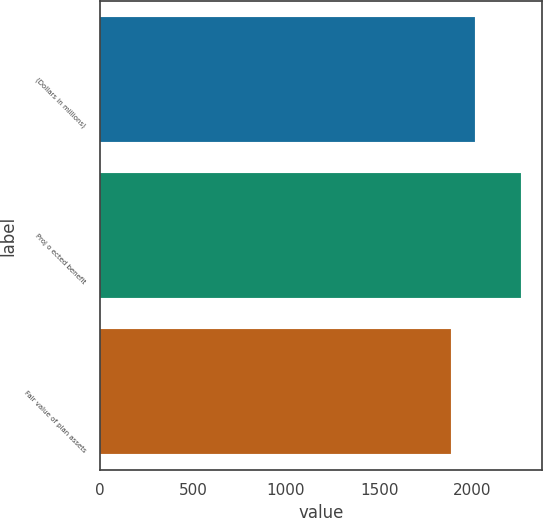Convert chart. <chart><loc_0><loc_0><loc_500><loc_500><bar_chart><fcel>(Dollars in millions)<fcel>Proj o ected benefit<fcel>Fair value of plan assets<nl><fcel>2015<fcel>2262<fcel>1887<nl></chart> 